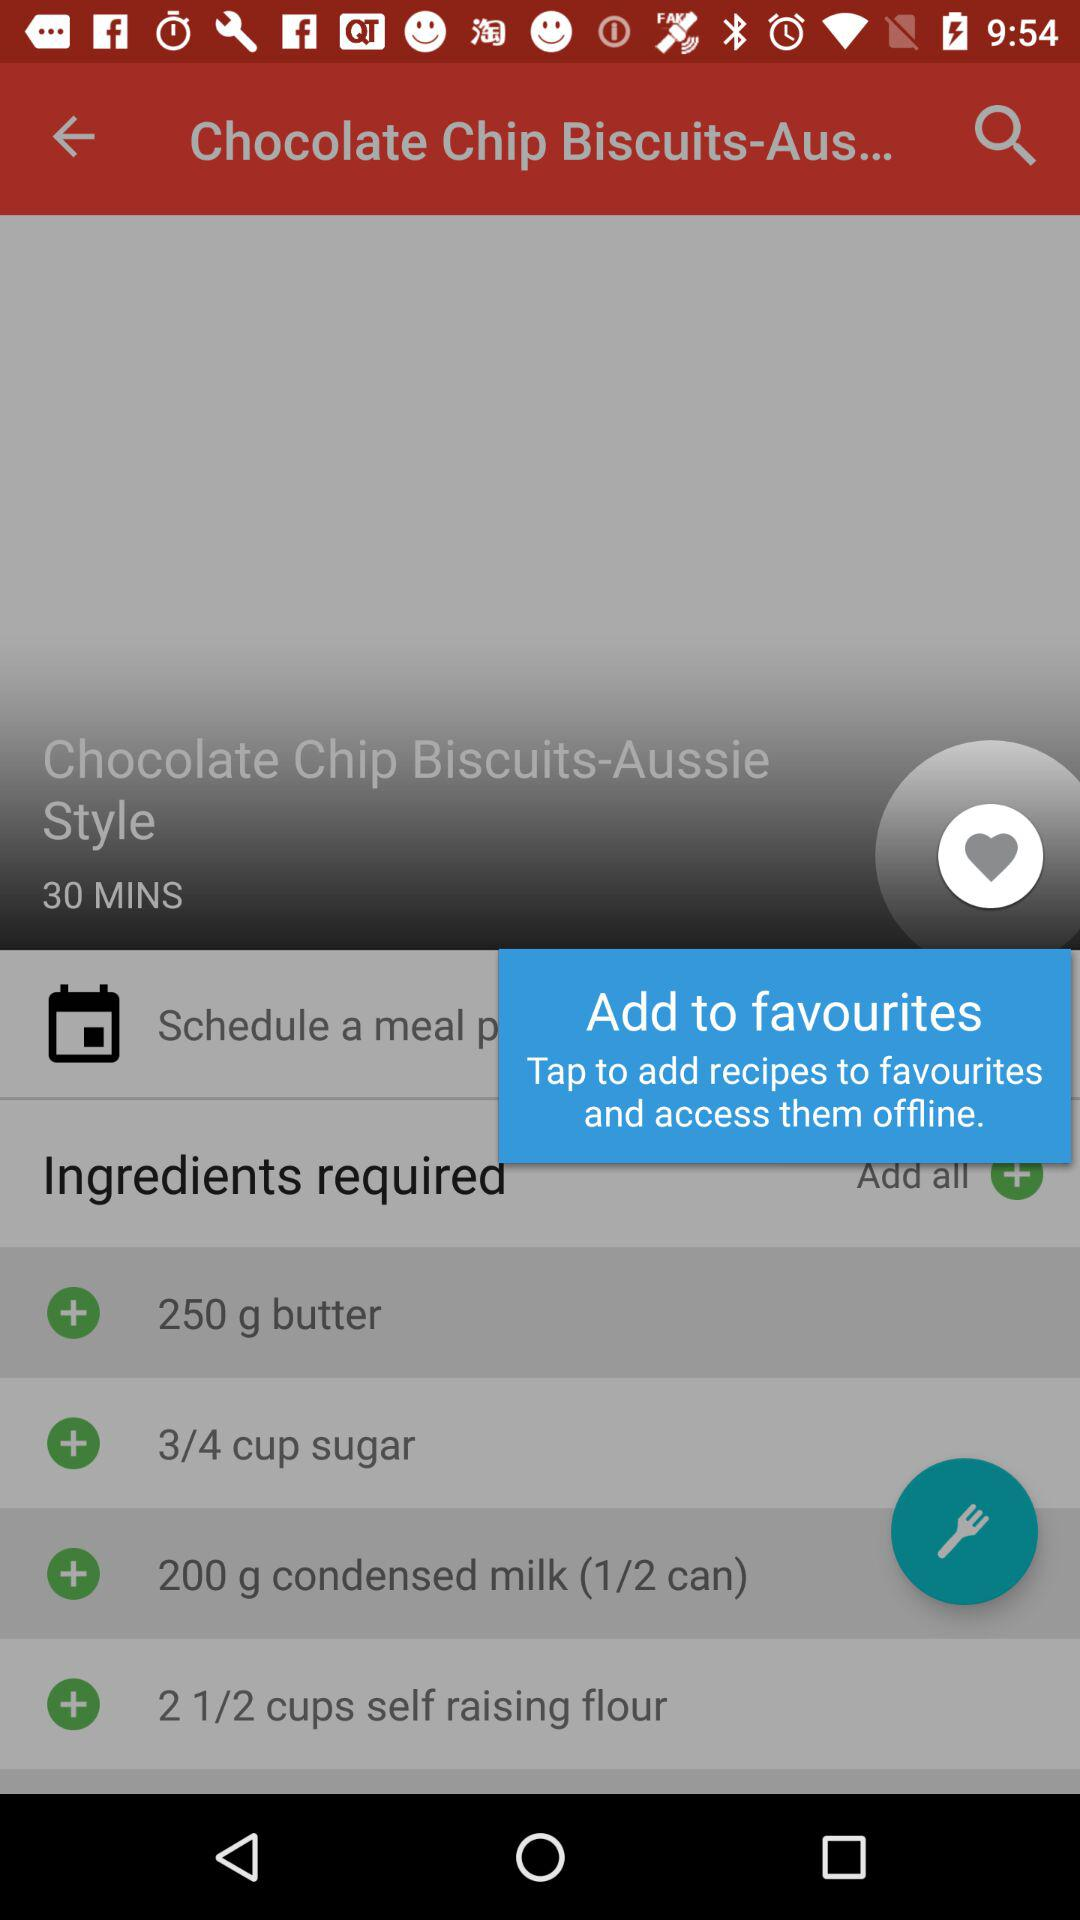How much time will it take to make the dish? It will take 30 minutes to make the dish. 